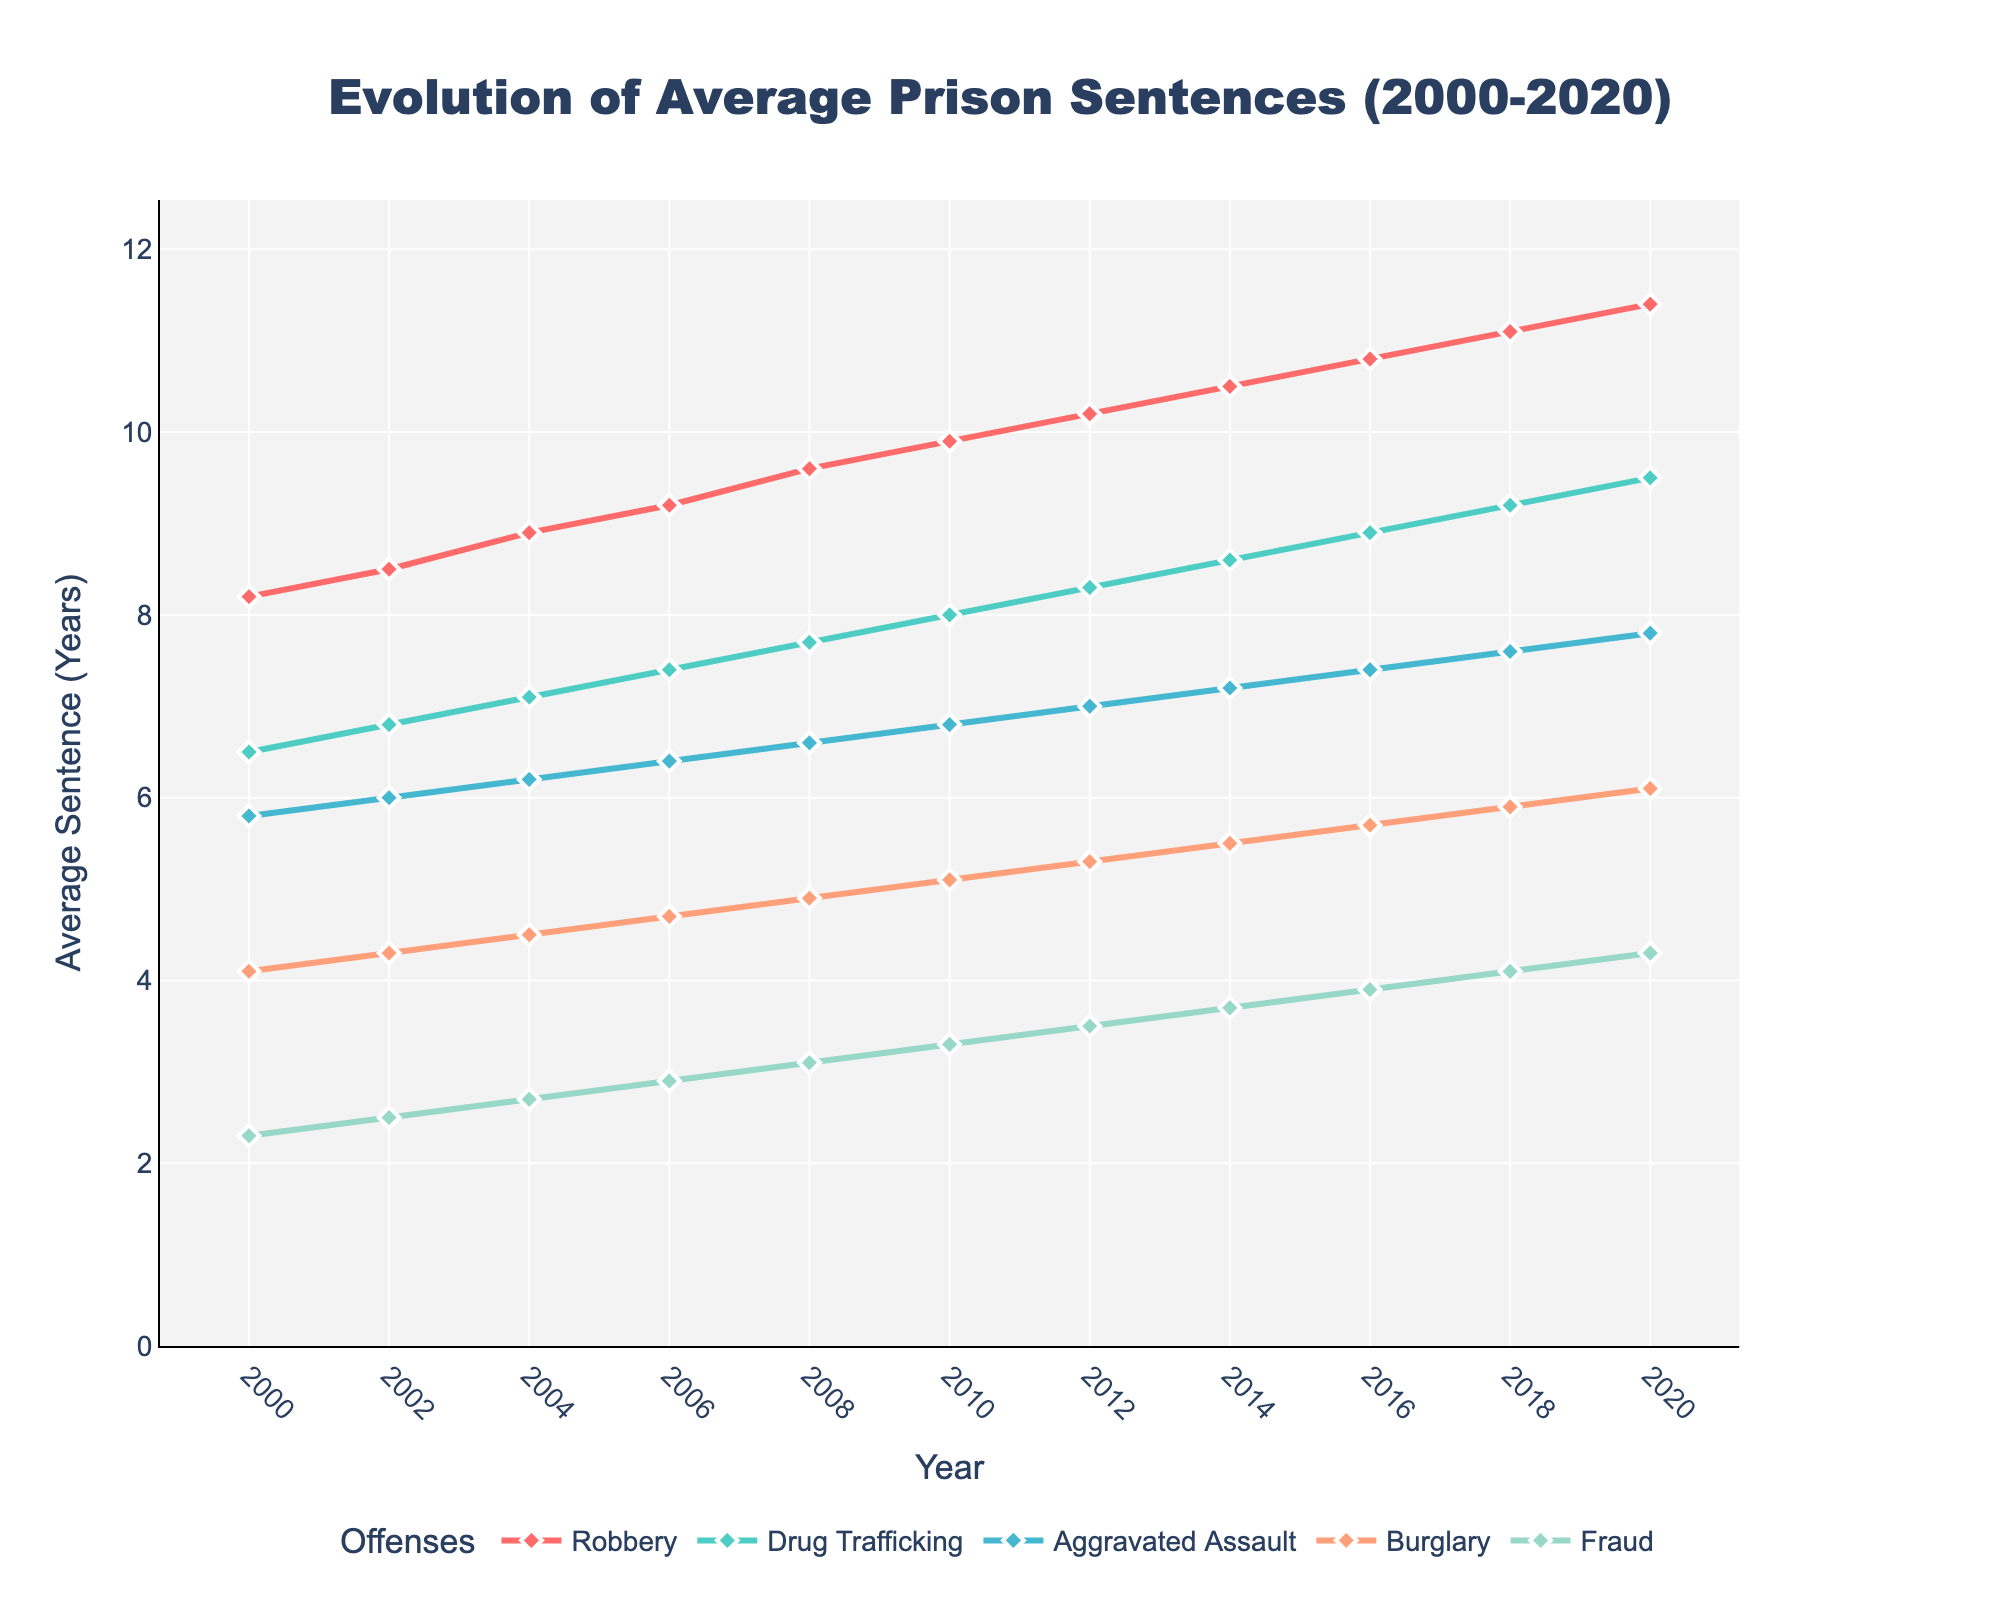What was the average prison sentence for Robbery in 2010? Identify the data point for Robbery in 2010 by following the line trace for Robbery to the year 2010. The average sentence is noted at that point.
Answer: 9.9 years Which offense had the shortest average prison sentence in 2020? Compare the data points for all offenses in 2020. The offense with the lowest numeric value has the shortest average prison sentence.
Answer: Fraud By how much did the average prison sentence for Drug Trafficking increase from 2000 to 2020? Subtract the average prison sentence for Drug Trafficking in 2000 from the value in 2020. (9.5 - 6.5 = 3.0)
Answer: 3.0 years Which offense saw the greatest increase in average prison sentences between 2000 and 2020? Calculate the difference between the 2000 and 2020 values for each offense. The offense with the largest difference experienced the greatest increase.
Answer: Robbery In what year did the average prison sentence for Aggravated Assault first exceed 7 years? Identify the point along the Aggravated Assault trace where the value first passes the 7-year mark.
Answer: 2012 Between 2004 and 2016, how much did the average prison sentence for Burglary increase? Subtract the value for Burglary in 2004 from the value in 2016. (5.7 - 4.5 = 1.2)
Answer: 1.2 years Which offense maintained the most consistent trend (least deviation) over the 20 years? Compare the visual slopes of line traces for all offenses. The least fluctuating line indicates the most consistent trend.
Answer: Aggravated Assault By how much did the average sentence for Fraud change from 2014 to 2018? Subtract the value for Fraud in 2014 from the value in 2018. (4.1 - 3.7 = 0.4)
Answer: 0.4 years What is the overall trend for average prison sentences for Robbery from 2000 to 2020? Observe the Robbery trace on the graph. The trend indicates a steady increase over the years.
Answer: Increasing Which year saw a higher average prison sentence for both Drug Trafficking and Fraud compared to the previous year? Look for the year where both Drug Trafficking and Fraud values are higher than their respective values in the previous year.
Answer: 2010 